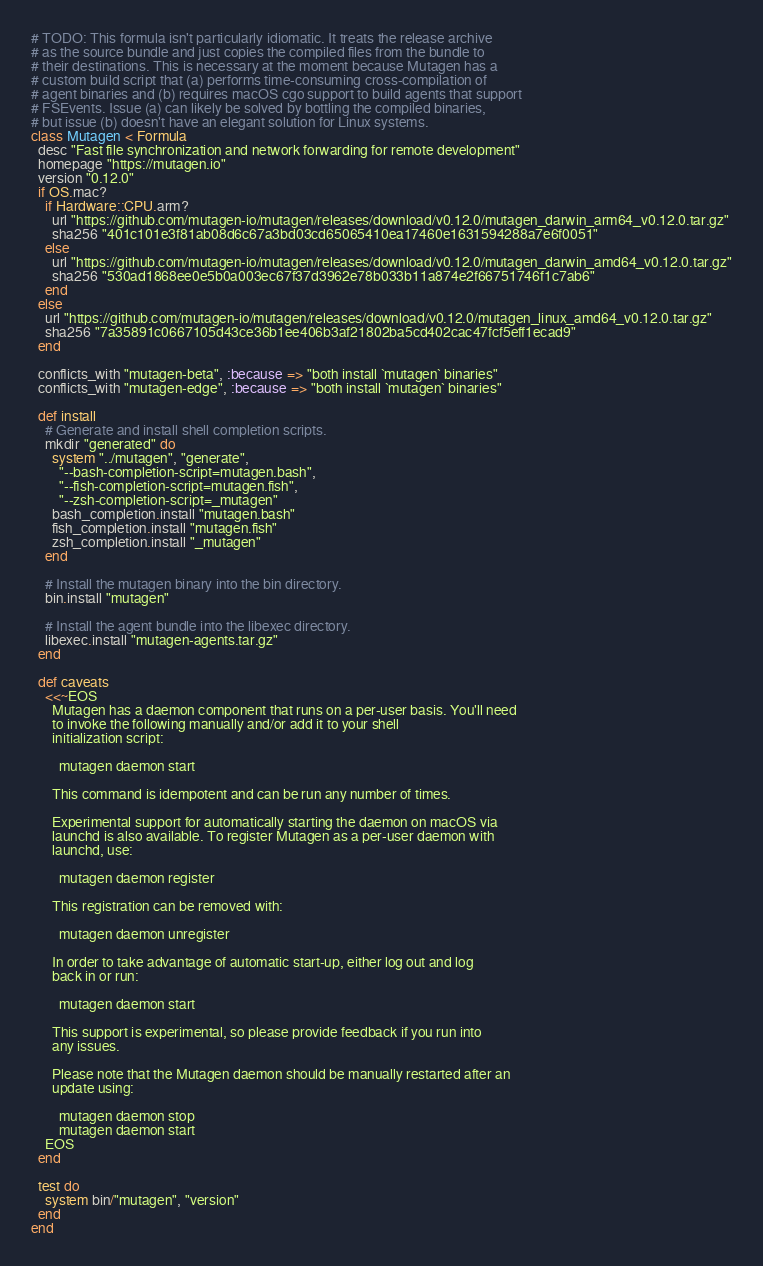Convert code to text. <code><loc_0><loc_0><loc_500><loc_500><_Ruby_># TODO: This formula isn't particularly idiomatic. It treats the release archive
# as the source bundle and just copies the compiled files from the bundle to
# their destinations. This is necessary at the moment because Mutagen has a
# custom build script that (a) performs time-consuming cross-compilation of
# agent binaries and (b) requires macOS cgo support to build agents that support
# FSEvents. Issue (a) can likely be solved by bottling the compiled binaries,
# but issue (b) doesn't have an elegant solution for Linux systems.
class Mutagen < Formula
  desc "Fast file synchronization and network forwarding for remote development"
  homepage "https://mutagen.io"
  version "0.12.0"
  if OS.mac?
    if Hardware::CPU.arm?
      url "https://github.com/mutagen-io/mutagen/releases/download/v0.12.0/mutagen_darwin_arm64_v0.12.0.tar.gz"
      sha256 "401c101e3f81ab08d6c67a3bd03cd65065410ea17460e1631594288a7e6f0051"
    else
      url "https://github.com/mutagen-io/mutagen/releases/download/v0.12.0/mutagen_darwin_amd64_v0.12.0.tar.gz"
      sha256 "530ad1868ee0e5b0a003ec67f37d3962e78b033b11a874e2f66751746f1c7ab6"
    end
  else
    url "https://github.com/mutagen-io/mutagen/releases/download/v0.12.0/mutagen_linux_amd64_v0.12.0.tar.gz"
    sha256 "7a35891c0667105d43ce36b1ee406b3af21802ba5cd402cac47fcf5eff1ecad9"
  end

  conflicts_with "mutagen-beta", :because => "both install `mutagen` binaries"
  conflicts_with "mutagen-edge", :because => "both install `mutagen` binaries"

  def install
    # Generate and install shell completion scripts.
    mkdir "generated" do
      system "../mutagen", "generate",
        "--bash-completion-script=mutagen.bash",
        "--fish-completion-script=mutagen.fish",
        "--zsh-completion-script=_mutagen"
      bash_completion.install "mutagen.bash"
      fish_completion.install "mutagen.fish"
      zsh_completion.install "_mutagen"
    end

    # Install the mutagen binary into the bin directory.
    bin.install "mutagen"

    # Install the agent bundle into the libexec directory.
    libexec.install "mutagen-agents.tar.gz"
  end

  def caveats
    <<~EOS
      Mutagen has a daemon component that runs on a per-user basis. You'll need
      to invoke the following manually and/or add it to your shell
      initialization script:

        mutagen daemon start

      This command is idempotent and can be run any number of times.

      Experimental support for automatically starting the daemon on macOS via
      launchd is also available. To register Mutagen as a per-user daemon with
      launchd, use:

        mutagen daemon register

      This registration can be removed with:

        mutagen daemon unregister

      In order to take advantage of automatic start-up, either log out and log
      back in or run:

        mutagen daemon start

      This support is experimental, so please provide feedback if you run into
      any issues.

      Please note that the Mutagen daemon should be manually restarted after an
      update using:

        mutagen daemon stop
        mutagen daemon start
    EOS
  end

  test do
    system bin/"mutagen", "version"
  end
end
</code> 